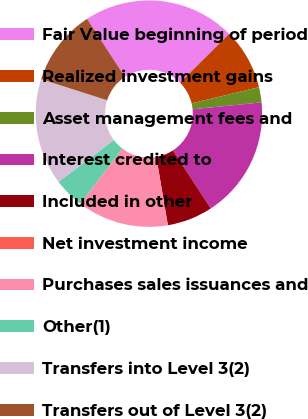Convert chart. <chart><loc_0><loc_0><loc_500><loc_500><pie_chart><fcel>Fair Value beginning of period<fcel>Realized investment gains<fcel>Asset management fees and<fcel>Interest credited to<fcel>Included in other<fcel>Net investment income<fcel>Purchases sales issuances and<fcel>Other(1)<fcel>Transfers into Level 3(2)<fcel>Transfers out of Level 3(2)<nl><fcel>21.74%<fcel>8.7%<fcel>2.17%<fcel>17.39%<fcel>6.52%<fcel>0.0%<fcel>13.04%<fcel>4.35%<fcel>15.22%<fcel>10.87%<nl></chart> 